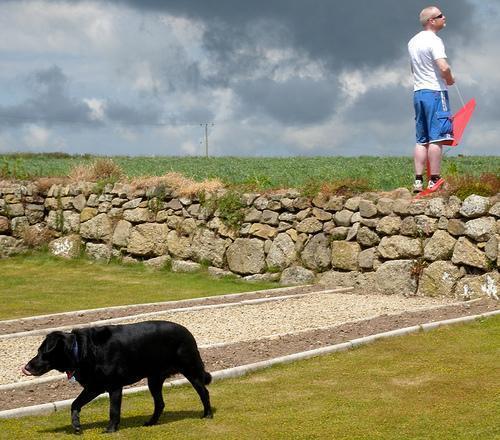What is the flag made of?
Indicate the correct response by choosing from the four available options to answer the question.
Options: Cloth, leather, plastic, rayon. Plastic. 